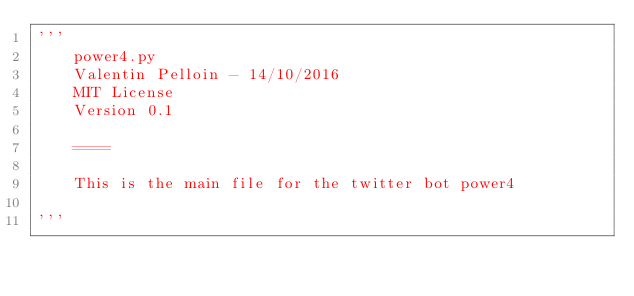Convert code to text. <code><loc_0><loc_0><loc_500><loc_500><_Python_>'''
    power4.py
    Valentin Pelloin - 14/10/2016
    MIT License
    Version 0.1

    ====

    This is the main file for the twitter bot power4

'''
</code> 